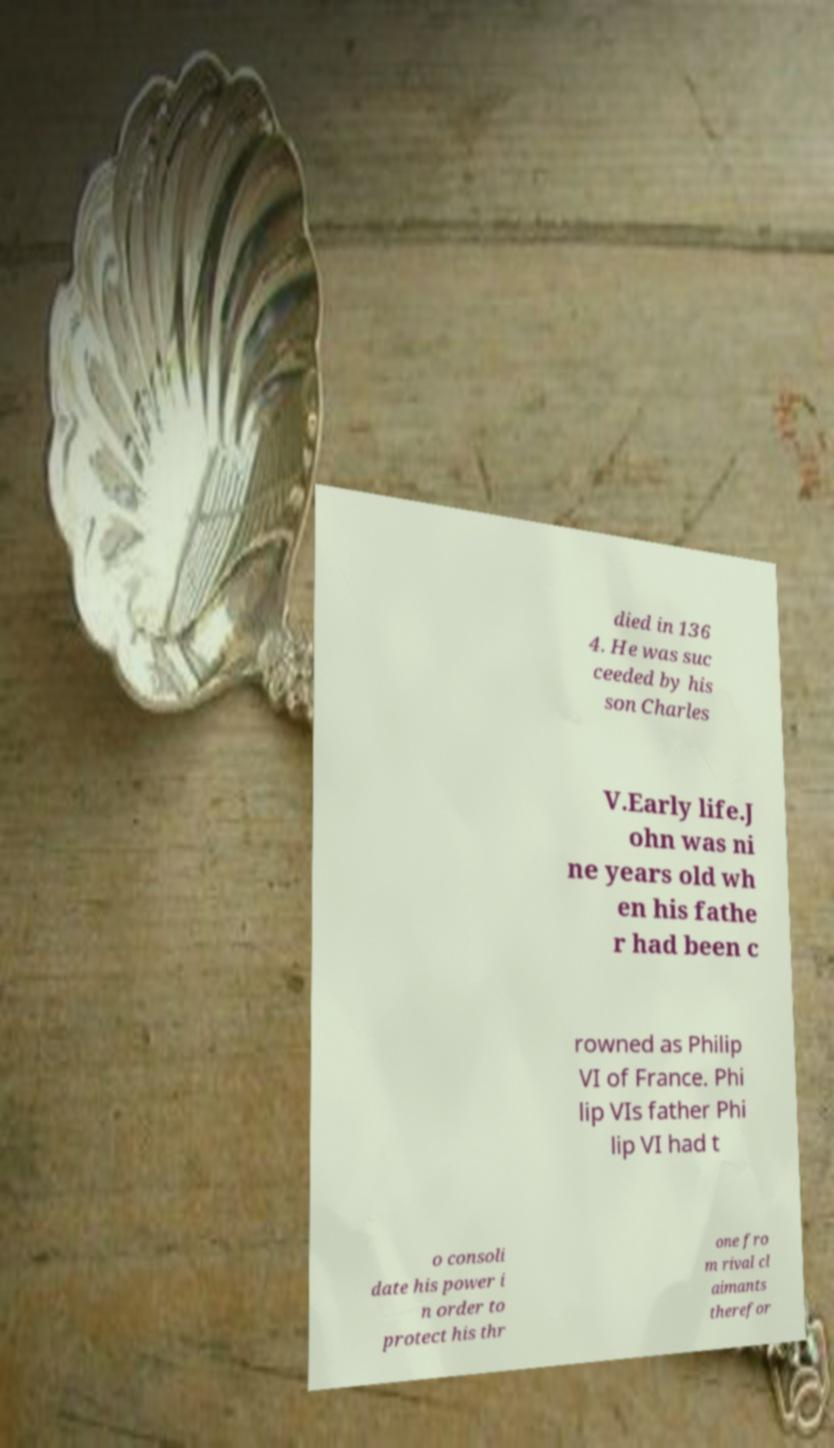What messages or text are displayed in this image? I need them in a readable, typed format. died in 136 4. He was suc ceeded by his son Charles V.Early life.J ohn was ni ne years old wh en his fathe r had been c rowned as Philip VI of France. Phi lip VIs father Phi lip VI had t o consoli date his power i n order to protect his thr one fro m rival cl aimants therefor 